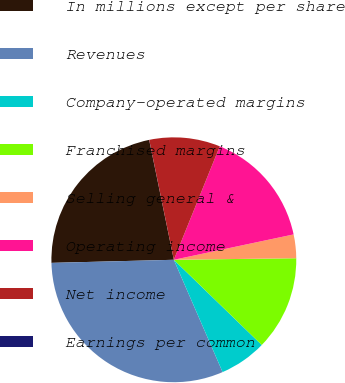<chart> <loc_0><loc_0><loc_500><loc_500><pie_chart><fcel>In millions except per share<fcel>Revenues<fcel>Company-operated margins<fcel>Franchised margins<fcel>Selling general &<fcel>Operating income<fcel>Net income<fcel>Earnings per common<nl><fcel>22.17%<fcel>31.12%<fcel>6.23%<fcel>12.45%<fcel>3.12%<fcel>15.56%<fcel>9.34%<fcel>0.01%<nl></chart> 